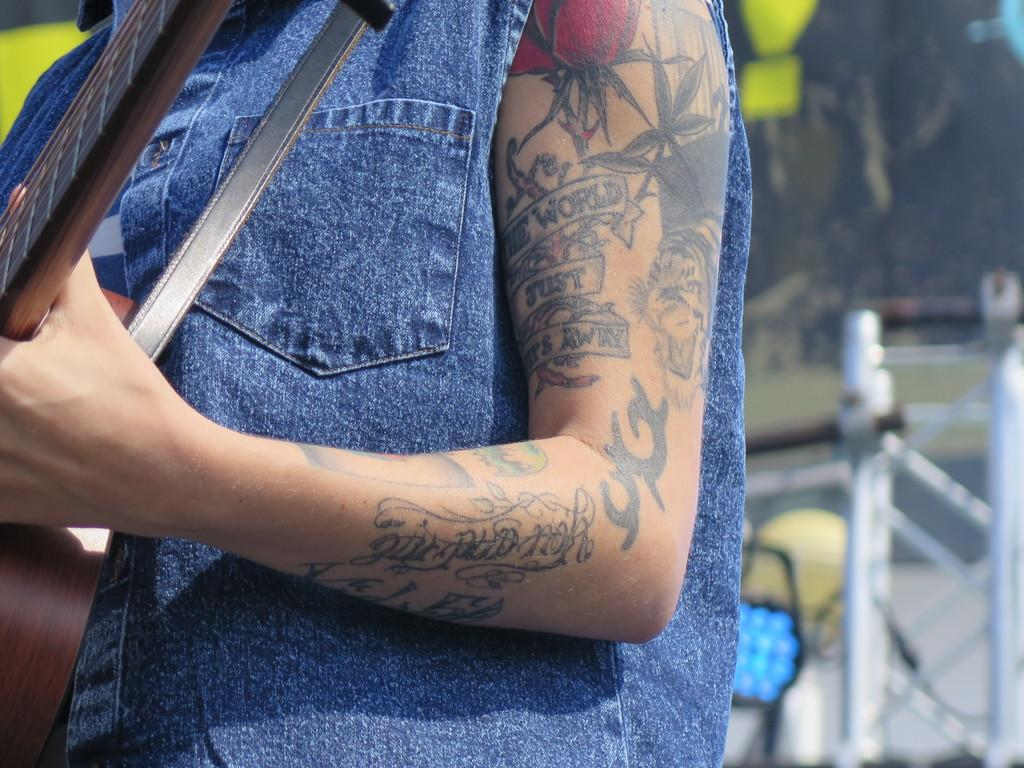What is the main subject of the image? There is a person in the image. What is the person wearing? The person is wearing clothes. What object is the person holding? The person is holding a guitar. What type of structure can be seen in the image? There is a fence in the image. How would you describe the background of the image? The background of the image is blurred. What type of quartz can be seen in the person's hand in the image? There is no quartz present in the image; the person is holding a guitar. Are there any fairies visible in the image? There are no fairies present in the image; it features a person holding a guitar and a fence in the background. 